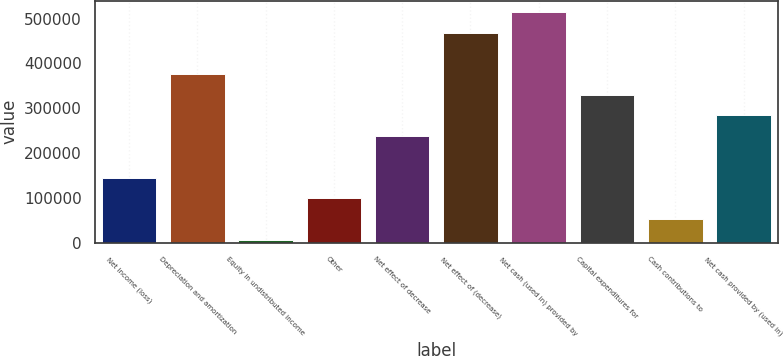<chart> <loc_0><loc_0><loc_500><loc_500><bar_chart><fcel>Net income (loss)<fcel>Depreciation and amortization<fcel>Equity in undistributed income<fcel>Other<fcel>Net effect of decrease<fcel>Net effect of (decrease)<fcel>Net cash (used in) provided by<fcel>Capital expenditures for<fcel>Cash contributions to<fcel>Net cash provided by (used in)<nl><fcel>145449<fcel>375968<fcel>7137<fcel>99344.8<fcel>237656<fcel>468176<fcel>514280<fcel>329864<fcel>53240.9<fcel>283760<nl></chart> 